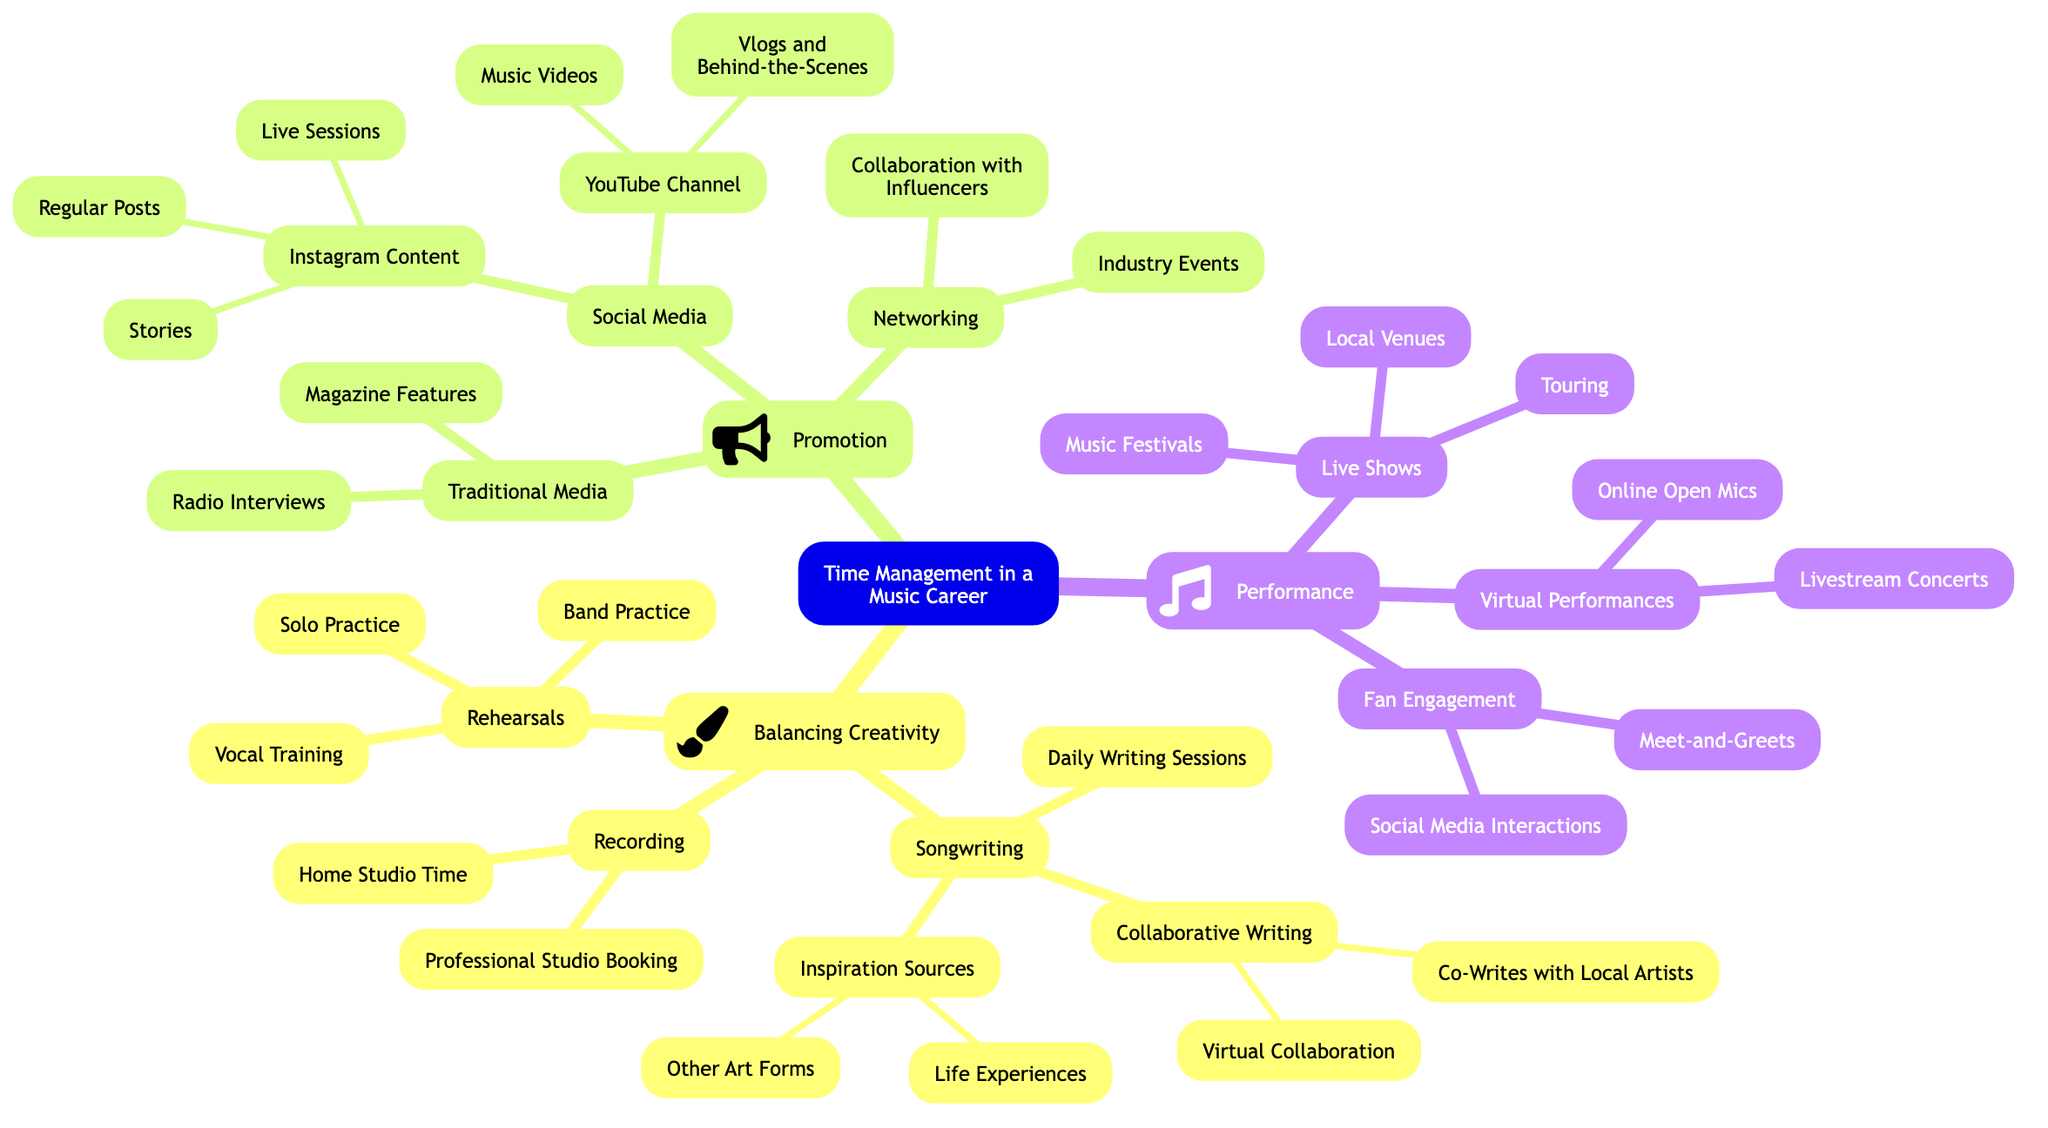What are the main branches of the mind map? The mind map has three main branches: "Balancing Creativity," "Promotion," and "Performance." Each serves to categorize important aspects of time management in a music career.
Answer: Balancing Creativity, Promotion, Performance How many sub-branches are under "Balancing Creativity"? The "Balancing Creativity" branch includes three sub-branches: "Songwriting," "Recording," and "Rehearsals." This indicates the different areas where time management is important for creative output.
Answer: 3 Which sub-branch includes virtual collaboration? The "Collaborative Writing" sub-branch within "Songwriting" includes "Virtual Collaboration" as one of its components, highlighting the importance of working with others even at a distance.
Answer: Collaborative Writing What types of performances are mentioned in the diagram? The "Performance" branch includes "Live Shows," "Virtual Performances," and "Fan Engagement," which shows a variety of ways to engage an audience.
Answer: Live Shows, Virtual Performances, Fan Engagement Which form of promotion has the most detailed sub-branches? The "Social Media" sub-branch contains the most detailed sub-branches with "Instagram Content" and "YouTube Channel," both having further options like regular posts and music videos, indicating an emphasis on online presence.
Answer: Social Media How many nodes are under "Fan Engagement"? Under "Fan Engagement," there are two nodes: "Meet-and-Greets" and "Social Media Interactions," showcasing ways to connect with fans.
Answer: 2 Which aspect of creativity involves training? The "Rehearsals" sub-branch includes "Vocal Training," which is a key aspect related to enhancing performance skills and artistic expression.
Answer: Vocal Training What is a potential source of inspiration listed in the diagram? The "Inspiration Sources" sub-branch reveals that "Life Experiences" is a potential source of inspiration for songwriters. This indicates how personal experiences feed into creative processes.
Answer: Life Experiences What type of content does the "YouTube Channel" sub-branch focus on? The "YouTube Channel" sub-branch includes "Music Videos" and "Vlogs and Behind-the-Scenes," emphasizing the importance of video content for promotion.
Answer: Music Videos, Vlogs and Behind-the-Scenes 